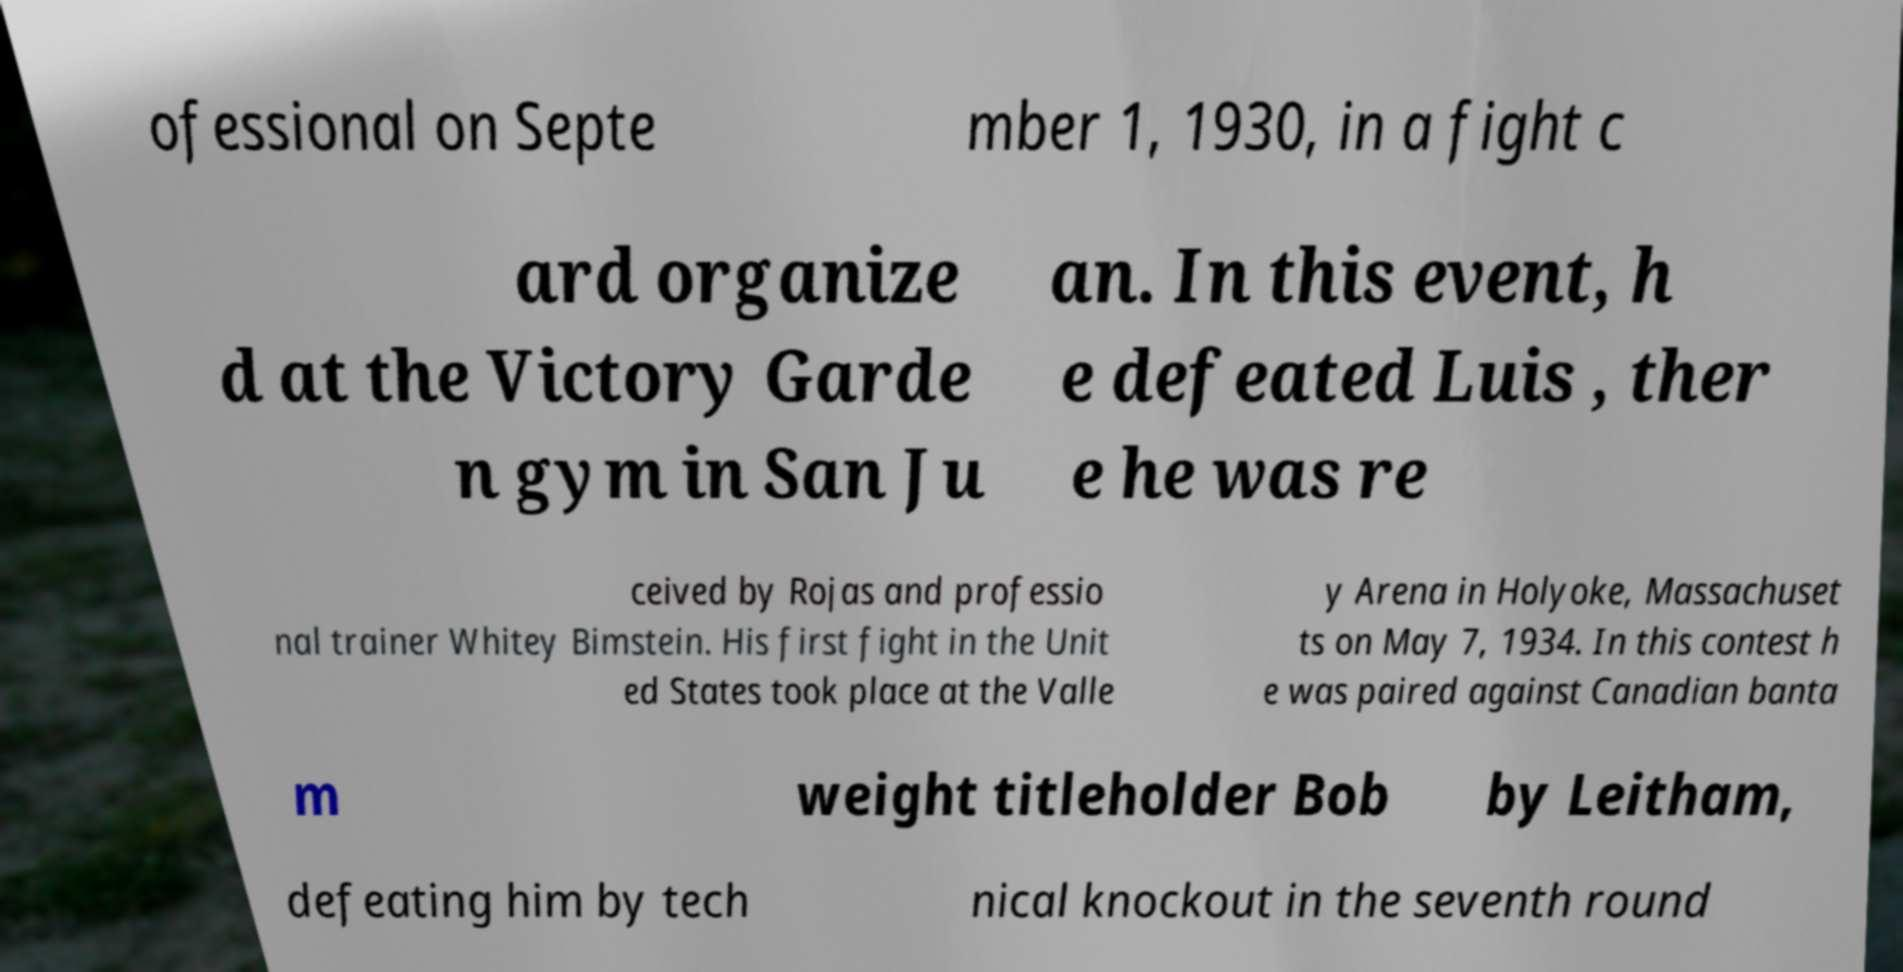Could you assist in decoding the text presented in this image and type it out clearly? ofessional on Septe mber 1, 1930, in a fight c ard organize d at the Victory Garde n gym in San Ju an. In this event, h e defeated Luis , ther e he was re ceived by Rojas and professio nal trainer Whitey Bimstein. His first fight in the Unit ed States took place at the Valle y Arena in Holyoke, Massachuset ts on May 7, 1934. In this contest h e was paired against Canadian banta m weight titleholder Bob by Leitham, defeating him by tech nical knockout in the seventh round 